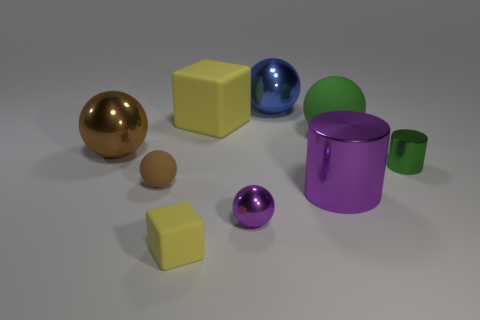Subtract all brown balls. How many were subtracted if there are1brown balls left? 1 Subtract all blue balls. How many balls are left? 4 Subtract all yellow spheres. Subtract all brown cubes. How many spheres are left? 5 Add 1 red metallic things. How many objects exist? 10 Subtract all cylinders. How many objects are left? 7 Add 8 small cyan shiny things. How many small cyan shiny things exist? 8 Subtract 1 purple spheres. How many objects are left? 8 Subtract all yellow rubber things. Subtract all green shiny cylinders. How many objects are left? 6 Add 7 brown metal balls. How many brown metal balls are left? 8 